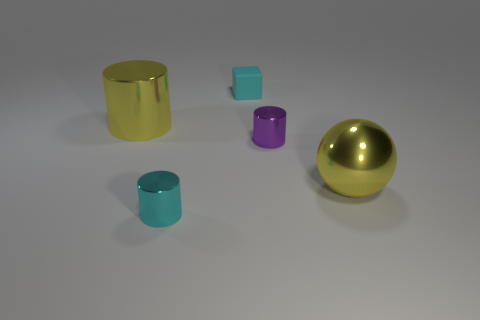Subtract all big yellow metallic cylinders. How many cylinders are left? 2 Add 2 cyan cubes. How many objects exist? 7 Subtract all purple cylinders. How many cylinders are left? 2 Subtract 0 yellow blocks. How many objects are left? 5 Subtract all balls. How many objects are left? 4 Subtract 1 blocks. How many blocks are left? 0 Subtract all yellow blocks. Subtract all red cylinders. How many blocks are left? 1 Subtract all gray cubes. How many yellow cylinders are left? 1 Subtract all small blue rubber cubes. Subtract all yellow objects. How many objects are left? 3 Add 2 small cyan things. How many small cyan things are left? 4 